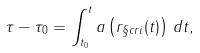<formula> <loc_0><loc_0><loc_500><loc_500>\tau - \tau _ { 0 } = \int _ { t _ { 0 } } ^ { t } a \left ( r _ { \S c r i } ( t ) \right ) \, d t ,</formula> 